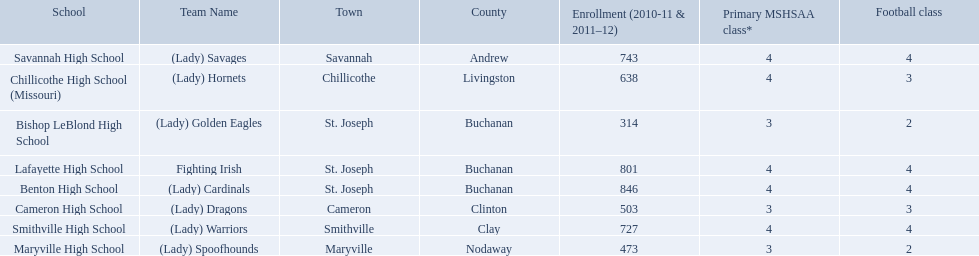What school in midland empire conference has 846 students enrolled? Benton High School. What school has 314 students enrolled? Bishop LeBlond High School. What school had 638 students enrolled? Chillicothe High School (Missouri). What team uses green and grey as colors? Fighting Irish. What is this team called? Lafayette High School. 